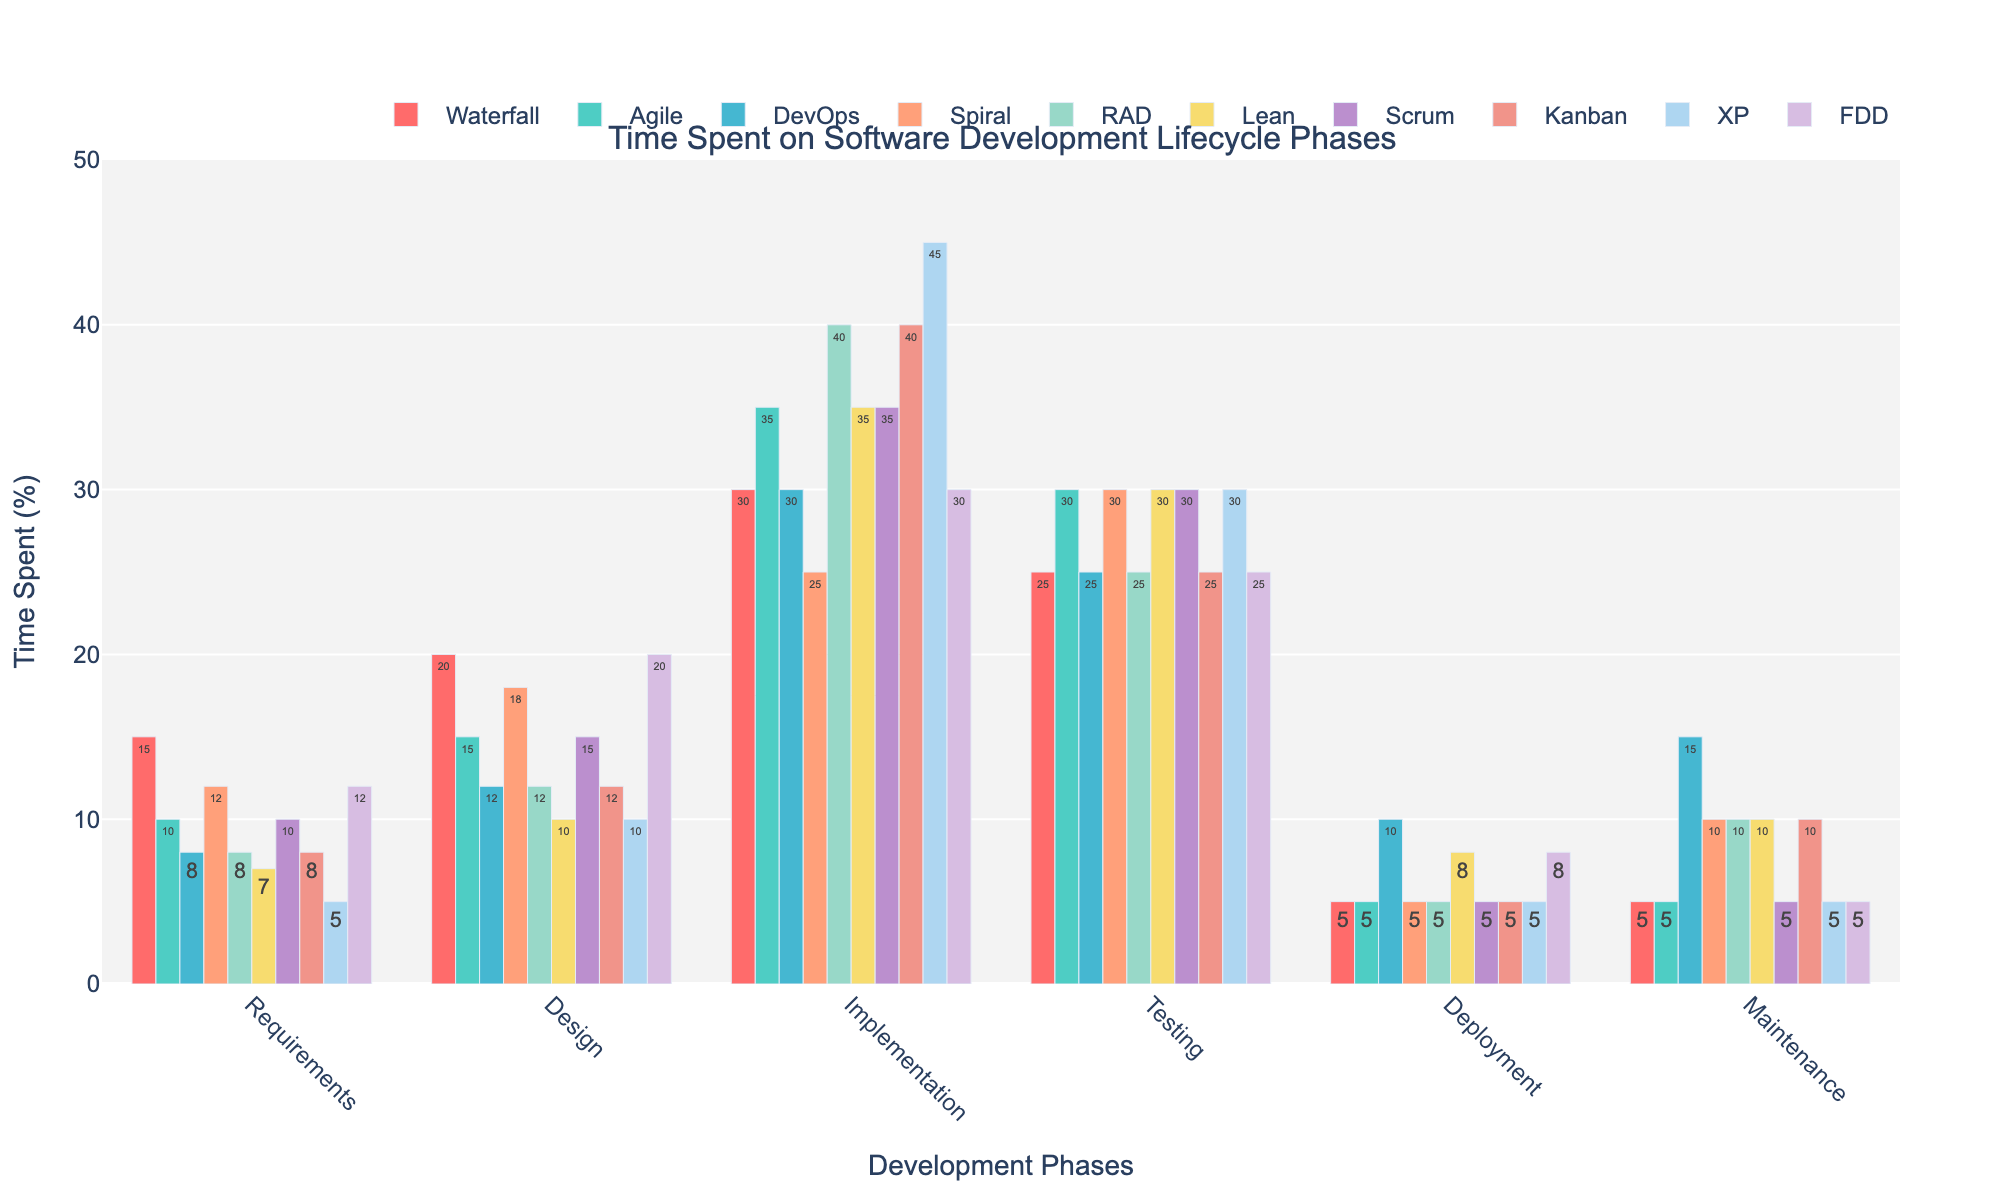Which methodology has the highest percentage of time spent on Design? By examining the bar heights for the Design phase across all methodologies, we observe that Waterfall and FDD both spend 20% of their time on Design, which is the highest value for this phase.
Answer: Waterfall and FDD How much more time does DevOps spend on Maintenance compared to Agile? DevOps spends 15% of its time on Maintenance, while Agile spends 5%. The difference is calculated as 15% - 5% = 10%.
Answer: 10% Which methodology has the lowest percentage of time allocated to Requirements? By observing the bars for the Requirements phase, XP has the lowest percentage at 5%.
Answer: XP What is the total percentage of time spent on Deployment and Maintenance combined for Lean? For Lean, Deployment takes 8% and Maintenance takes 10%. Summing them up gives 8% + 10% = 18%.
Answer: 18% What is the average time spent on Implementation across all methodologies? Adding the time spent on Implementation for all methodologies (30 + 35 + 30 + 25 + 40 + 35 + 35 + 40 + 45 + 30) yields 345%. Dividing by the number of methodologies (10) gives an average of 345% / 10 = 34.5%.
Answer: 34.5% Which methodology dedicates the most time to Testing, and how much is it? The highest bar for Testing belongs to Spiral, which dedicates 30% of its time to this phase.
Answer: Spiral, 30% Which two methodologies have an equal allocation of time for Deployment? By observing the bars for Deployment, Agile and Scrum both allocate 5% of their time to this phase.
Answer: Agile and Scrum What is the difference in time spent on Design between Agile and Lean? Agile spends 15% of its time on Design, while Lean spends 10%. The difference is calculated as 15% - 10% = 5%.
Answer: 5% What is the combined time spent on Requirements and Testing for Waterfall? Waterfall spends 15% on Requirements and 25% on Testing. Combined, it is 15% + 25% = 40%.
Answer: 40% 